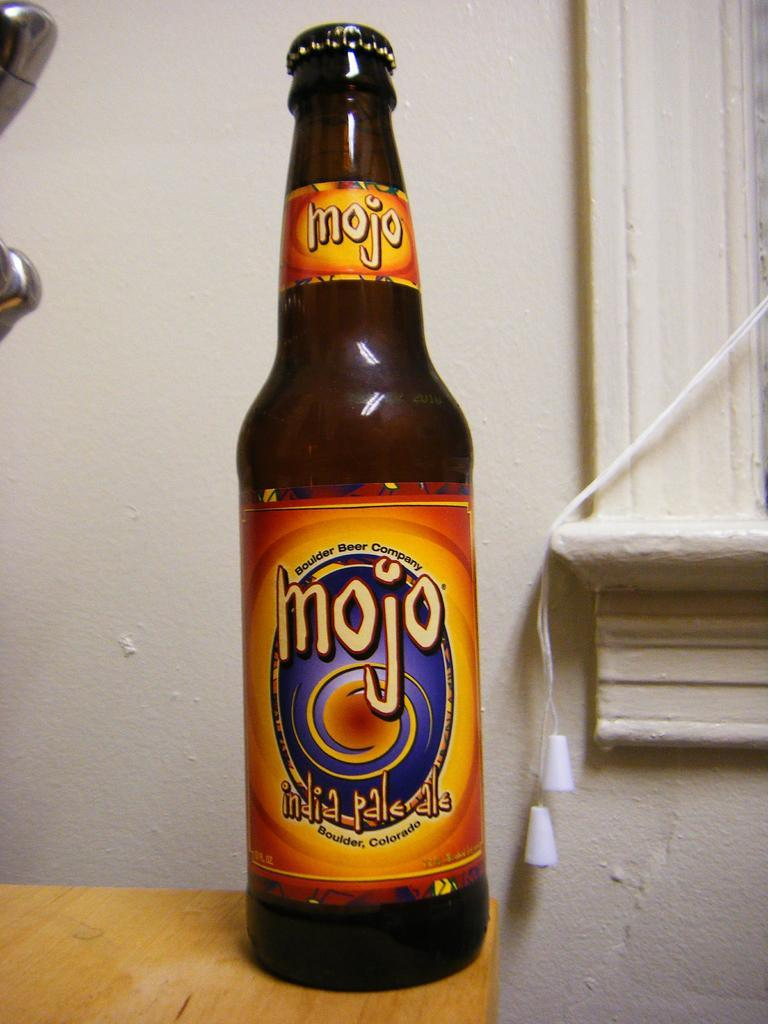<image>
Relay a brief, clear account of the picture shown. a bottle of mojo india palrdle with an orange label 